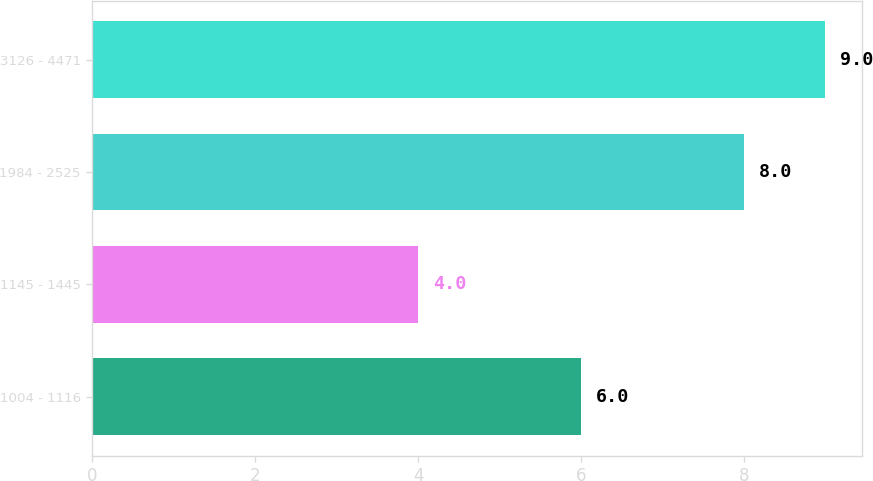Convert chart to OTSL. <chart><loc_0><loc_0><loc_500><loc_500><bar_chart><fcel>1004 - 1116<fcel>1145 - 1445<fcel>1984 - 2525<fcel>3126 - 4471<nl><fcel>6<fcel>4<fcel>8<fcel>9<nl></chart> 